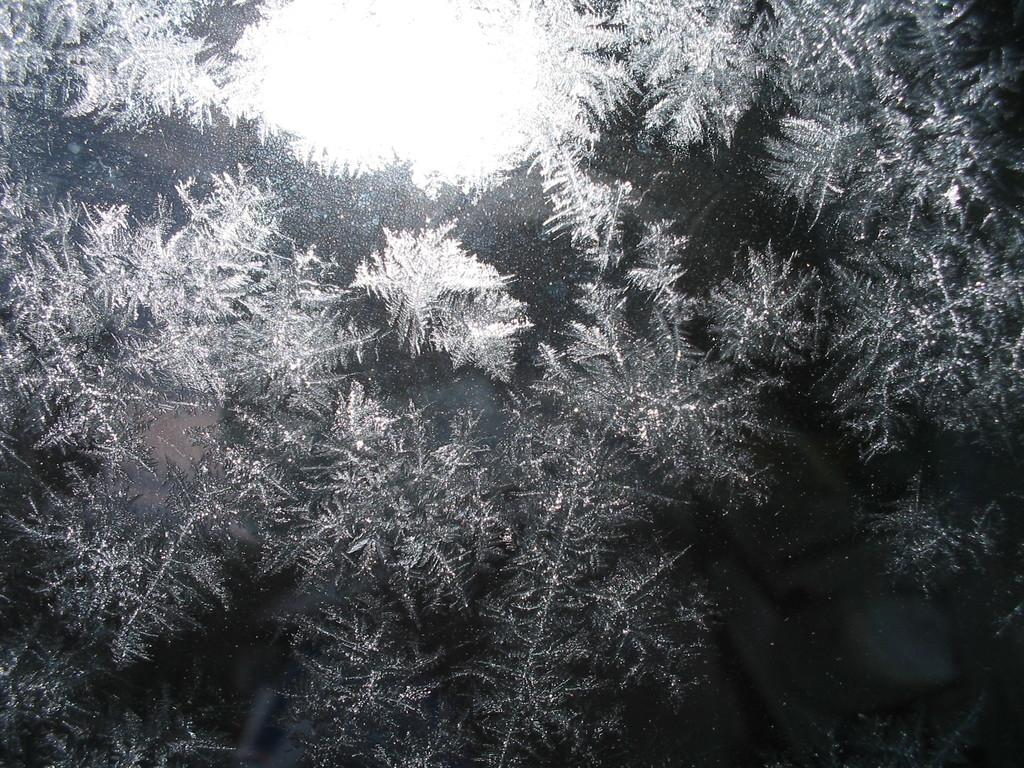What type of natural elements can be seen in the image? There are trees in the image. What is the color scheme of the image? The image is in black and white. How many beds are visible in the image? There are no beds present in the image. What type of emotion can be seen on the trees' noses in the image? Trees do not have noses, and therefore, no emotions can be observed on them. 